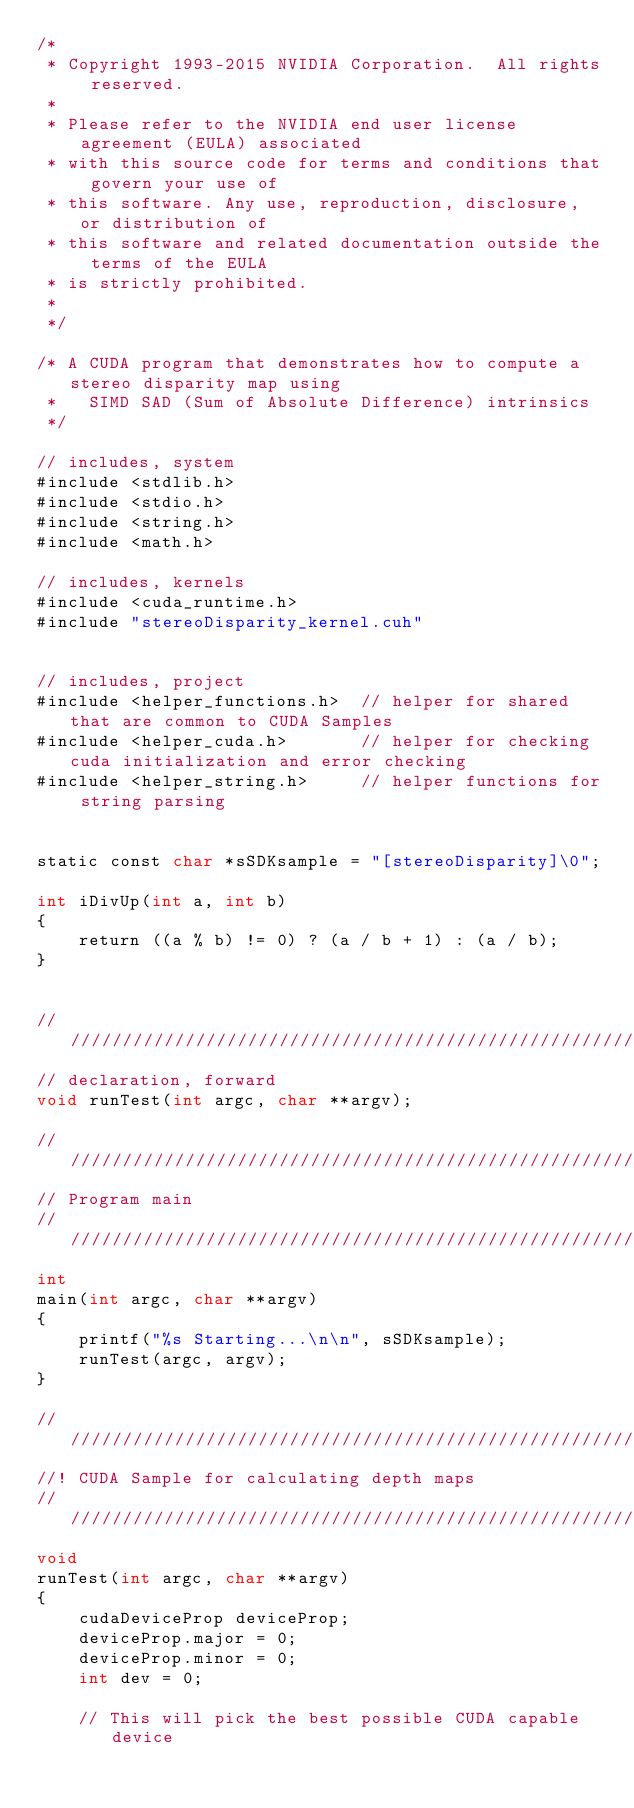<code> <loc_0><loc_0><loc_500><loc_500><_Cuda_>/*
 * Copyright 1993-2015 NVIDIA Corporation.  All rights reserved.
 *
 * Please refer to the NVIDIA end user license agreement (EULA) associated
 * with this source code for terms and conditions that govern your use of
 * this software. Any use, reproduction, disclosure, or distribution of
 * this software and related documentation outside the terms of the EULA
 * is strictly prohibited.
 *
 */

/* A CUDA program that demonstrates how to compute a stereo disparity map using
 *   SIMD SAD (Sum of Absolute Difference) intrinsics
 */

// includes, system
#include <stdlib.h>
#include <stdio.h>
#include <string.h>
#include <math.h>

// includes, kernels
#include <cuda_runtime.h>
#include "stereoDisparity_kernel.cuh"


// includes, project
#include <helper_functions.h>  // helper for shared that are common to CUDA Samples
#include <helper_cuda.h>       // helper for checking cuda initialization and error checking
#include <helper_string.h>     // helper functions for string parsing


static const char *sSDKsample = "[stereoDisparity]\0";

int iDivUp(int a, int b)
{
    return ((a % b) != 0) ? (a / b + 1) : (a / b);
}


////////////////////////////////////////////////////////////////////////////////
// declaration, forward
void runTest(int argc, char **argv);

////////////////////////////////////////////////////////////////////////////////
// Program main
////////////////////////////////////////////////////////////////////////////////
int
main(int argc, char **argv)
{
    printf("%s Starting...\n\n", sSDKsample);
    runTest(argc, argv);
}

////////////////////////////////////////////////////////////////////////////////
//! CUDA Sample for calculating depth maps
////////////////////////////////////////////////////////////////////////////////
void
runTest(int argc, char **argv)
{
    cudaDeviceProp deviceProp;
    deviceProp.major = 0;
    deviceProp.minor = 0;
    int dev = 0;

    // This will pick the best possible CUDA capable device</code> 